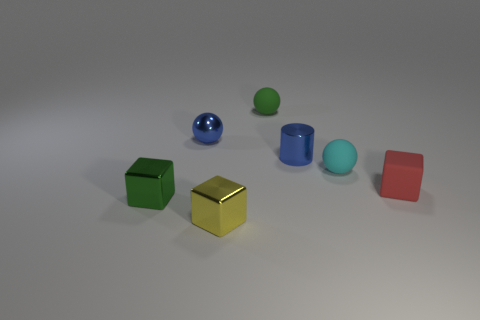Subtract all tiny green spheres. How many spheres are left? 2 Add 3 tiny blue metal balls. How many objects exist? 10 Subtract all green blocks. How many blocks are left? 2 Subtract all yellow cylinders. How many red balls are left? 0 Subtract all tiny blue cylinders. Subtract all brown rubber balls. How many objects are left? 6 Add 7 blue spheres. How many blue spheres are left? 8 Add 4 shiny balls. How many shiny balls exist? 5 Subtract 0 gray balls. How many objects are left? 7 Subtract all cubes. How many objects are left? 4 Subtract 1 spheres. How many spheres are left? 2 